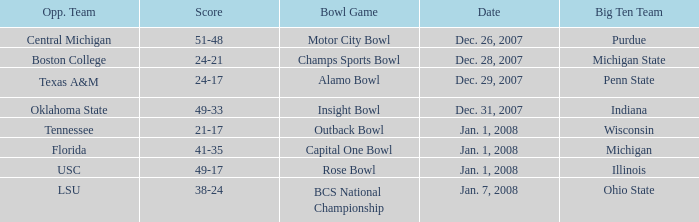What bowl game was played on Dec. 26, 2007? Motor City Bowl. 